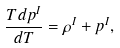Convert formula to latex. <formula><loc_0><loc_0><loc_500><loc_500>\frac { T d p ^ { I } } { d T } = \rho ^ { I } + p ^ { I } ,</formula> 